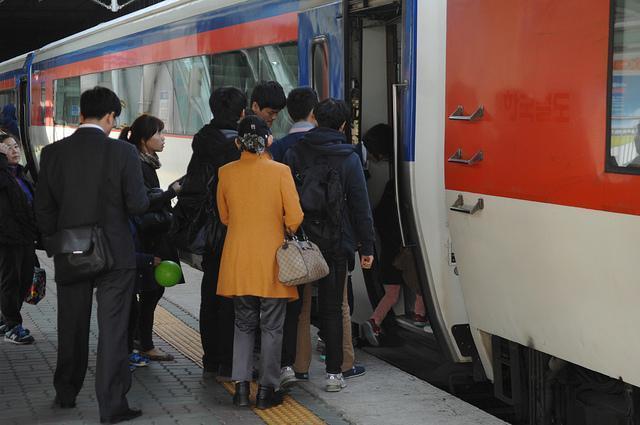How many backpacks are there?
Give a very brief answer. 2. How many people are in the picture?
Give a very brief answer. 7. 